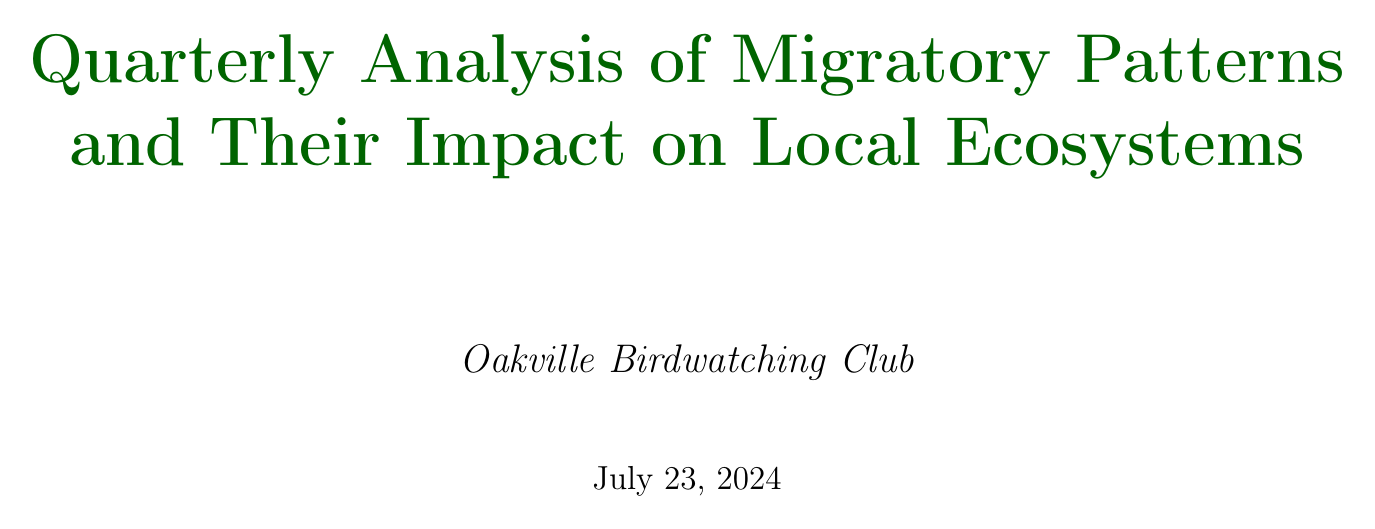What is the title of the report? The title of the report is mentioned at the top of the document.
Answer: Quarterly Analysis of Migratory Patterns and Their Impact on Local Ecosystems Which species shows a slight decrease in population trend? The document lists the population trends for three major migratory species, including the one that shows a slight decrease.
Answer: Canada Warbler What is the observation period for the Scarlet Tanager? The observation period for each migratory species is specified in the document.
Answer: Early May to mid-June What initiative is aimed at enhancing stopover habitats? The report describes various conservation efforts, including one focused on stopover habitats.
Answer: Oakville Harbours Flyway Project How much has biodiversity increased in reported backyards? The impact of the Backyard Bird Sanctuary Program is quantified in the document.
Answer: 20% What challenge involves the timing of migrations? The document discusses specific challenges faced by migratory birds, including one related to climate change.
Answer: Climate change affecting timing of migrations What type of population control is mentioned in the ecosystem impacts? The document provides specific examples of how migratory birds contribute to insect population control.
Answer: Insect Population Control What is the summary of the conclusion? The conclusion summarizes the overall findings regarding migratory patterns and their importance.
Answer: Promising trends and areas of concern What is one recommendation made in the report? Recommendations are provided at the end, suggesting actions to support migratory species.
Answer: Increase monitoring efforts at Rattray Marsh Conservation Area 